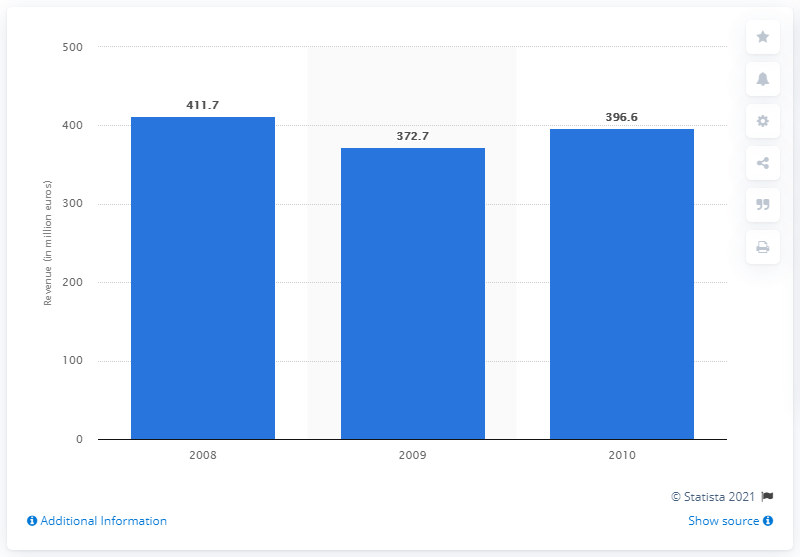Mention a couple of crucial points in this snapshot. In 2010, the Maritim Hotel Group generated a revenue of 396.6 million. 